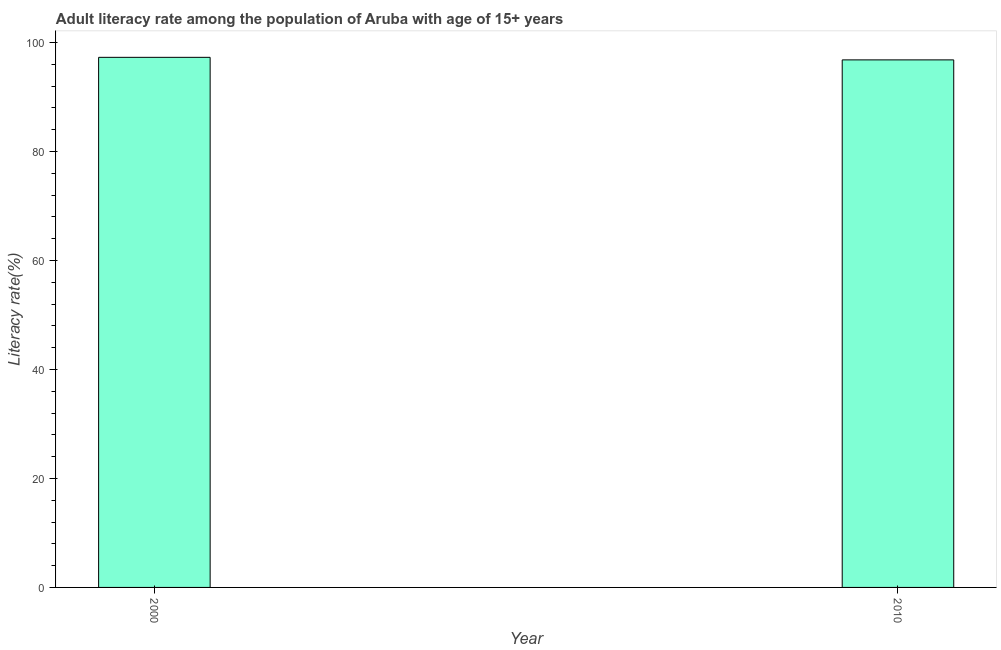Does the graph contain grids?
Keep it short and to the point. No. What is the title of the graph?
Your response must be concise. Adult literacy rate among the population of Aruba with age of 15+ years. What is the label or title of the Y-axis?
Make the answer very short. Literacy rate(%). What is the adult literacy rate in 2000?
Give a very brief answer. 97.29. Across all years, what is the maximum adult literacy rate?
Offer a terse response. 97.29. Across all years, what is the minimum adult literacy rate?
Provide a succinct answer. 96.82. In which year was the adult literacy rate maximum?
Provide a succinct answer. 2000. In which year was the adult literacy rate minimum?
Provide a succinct answer. 2010. What is the sum of the adult literacy rate?
Make the answer very short. 194.11. What is the difference between the adult literacy rate in 2000 and 2010?
Your response must be concise. 0.47. What is the average adult literacy rate per year?
Make the answer very short. 97.06. What is the median adult literacy rate?
Your answer should be compact. 97.06. In how many years, is the adult literacy rate greater than 72 %?
Provide a short and direct response. 2. Do a majority of the years between 2000 and 2010 (inclusive) have adult literacy rate greater than 84 %?
Keep it short and to the point. Yes. How many bars are there?
Offer a terse response. 2. Are all the bars in the graph horizontal?
Provide a short and direct response. No. What is the Literacy rate(%) of 2000?
Your response must be concise. 97.29. What is the Literacy rate(%) in 2010?
Your answer should be very brief. 96.82. What is the difference between the Literacy rate(%) in 2000 and 2010?
Make the answer very short. 0.47. 